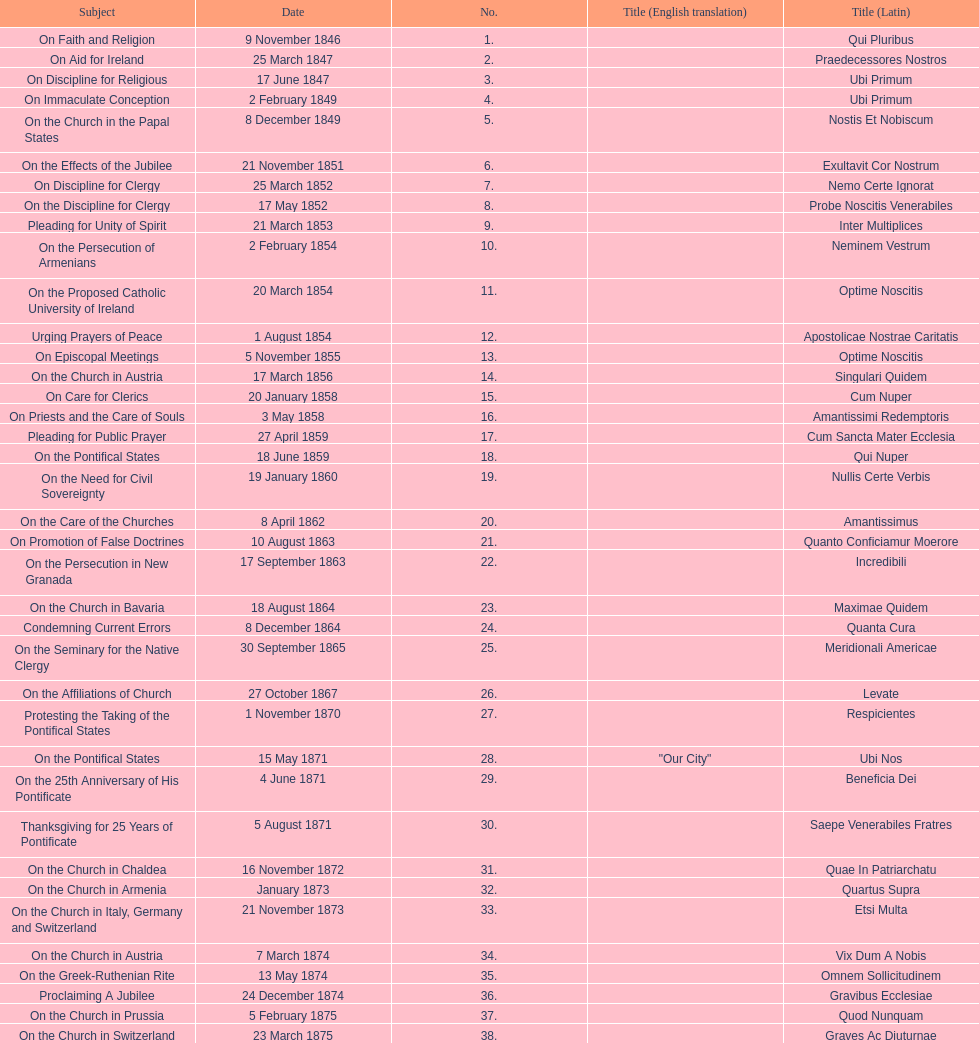Date of the last encyclical whose subject contained the word "pontificate" 5 August 1871. 